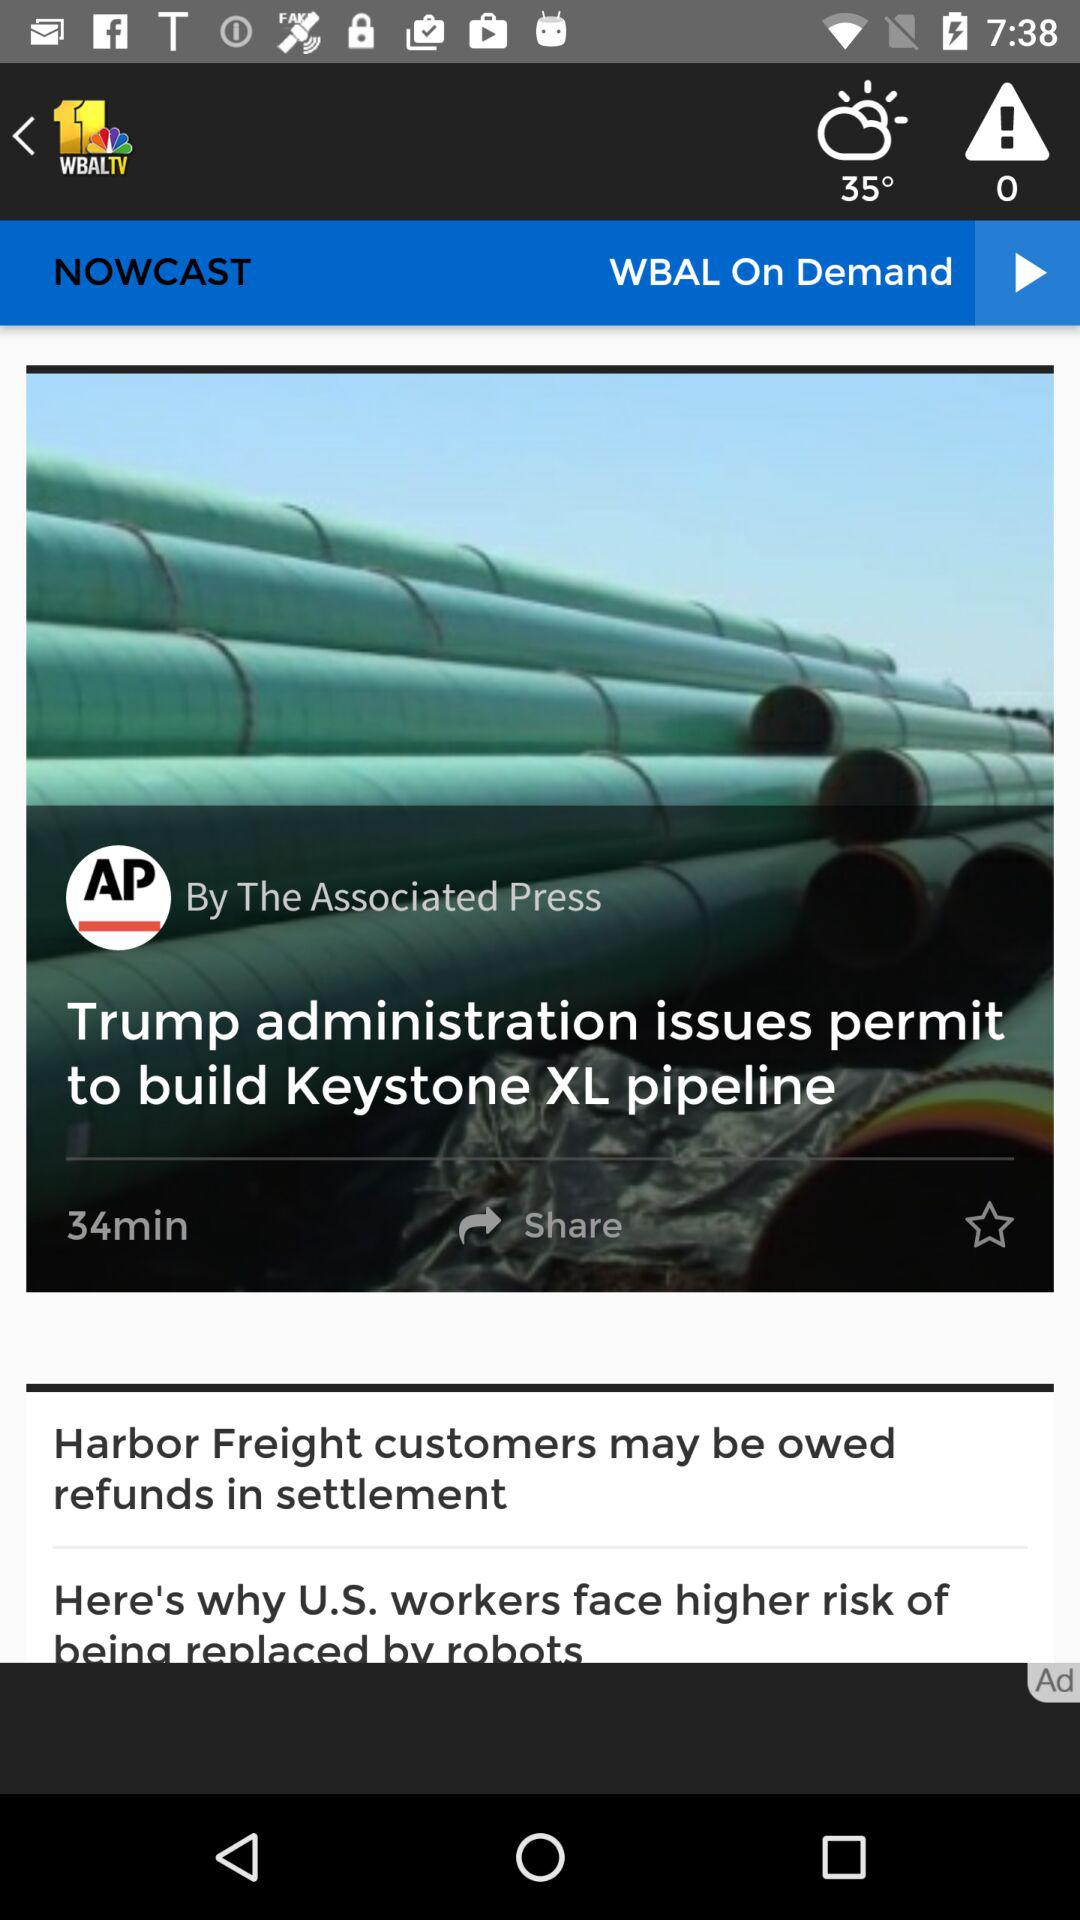Who is the author of the article? The author of the article is "The Associated Press". 